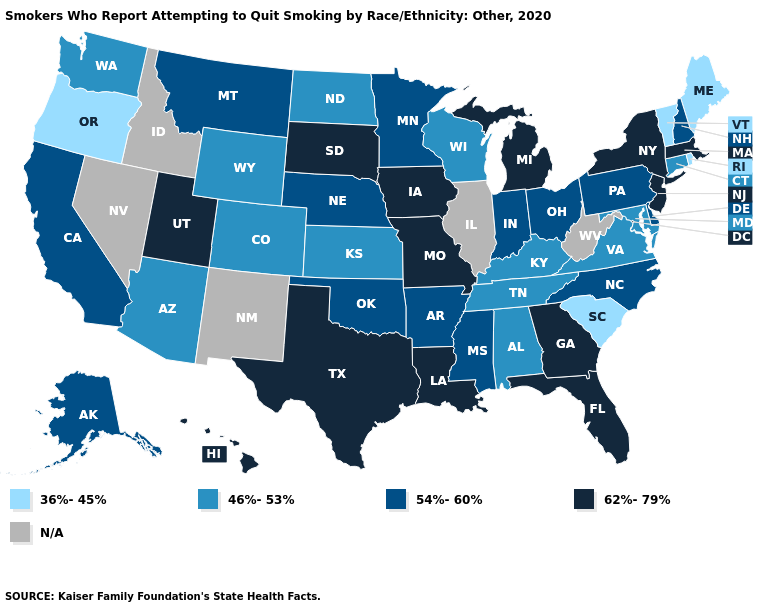Does Wisconsin have the lowest value in the MidWest?
Write a very short answer. Yes. Among the states that border Oregon , which have the lowest value?
Short answer required. Washington. Is the legend a continuous bar?
Keep it brief. No. What is the value of New Mexico?
Quick response, please. N/A. What is the value of West Virginia?
Keep it brief. N/A. What is the value of Rhode Island?
Quick response, please. 36%-45%. Among the states that border Missouri , does Arkansas have the highest value?
Write a very short answer. No. Name the states that have a value in the range 62%-79%?
Short answer required. Florida, Georgia, Hawaii, Iowa, Louisiana, Massachusetts, Michigan, Missouri, New Jersey, New York, South Dakota, Texas, Utah. What is the value of Illinois?
Concise answer only. N/A. Does the map have missing data?
Answer briefly. Yes. What is the value of Virginia?
Quick response, please. 46%-53%. Name the states that have a value in the range N/A?
Quick response, please. Idaho, Illinois, Nevada, New Mexico, West Virginia. Does Oregon have the lowest value in the West?
Short answer required. Yes. Name the states that have a value in the range 54%-60%?
Keep it brief. Alaska, Arkansas, California, Delaware, Indiana, Minnesota, Mississippi, Montana, Nebraska, New Hampshire, North Carolina, Ohio, Oklahoma, Pennsylvania. 